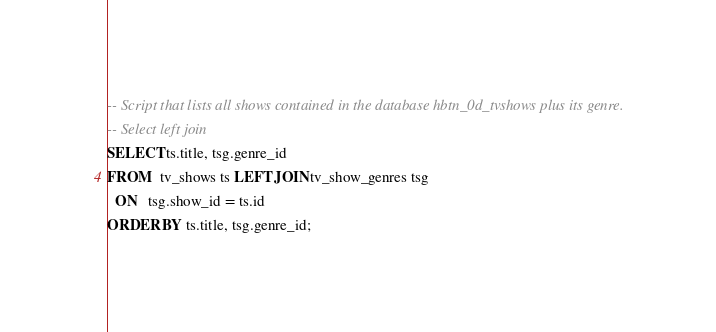Convert code to text. <code><loc_0><loc_0><loc_500><loc_500><_SQL_>-- Script that lists all shows contained in the database hbtn_0d_tvshows plus its genre.
-- Select left join
SELECT ts.title, tsg.genre_id
FROM   tv_shows ts LEFT JOIN tv_show_genres tsg
  ON   tsg.show_id = ts.id
ORDER BY ts.title, tsg.genre_id;
</code> 